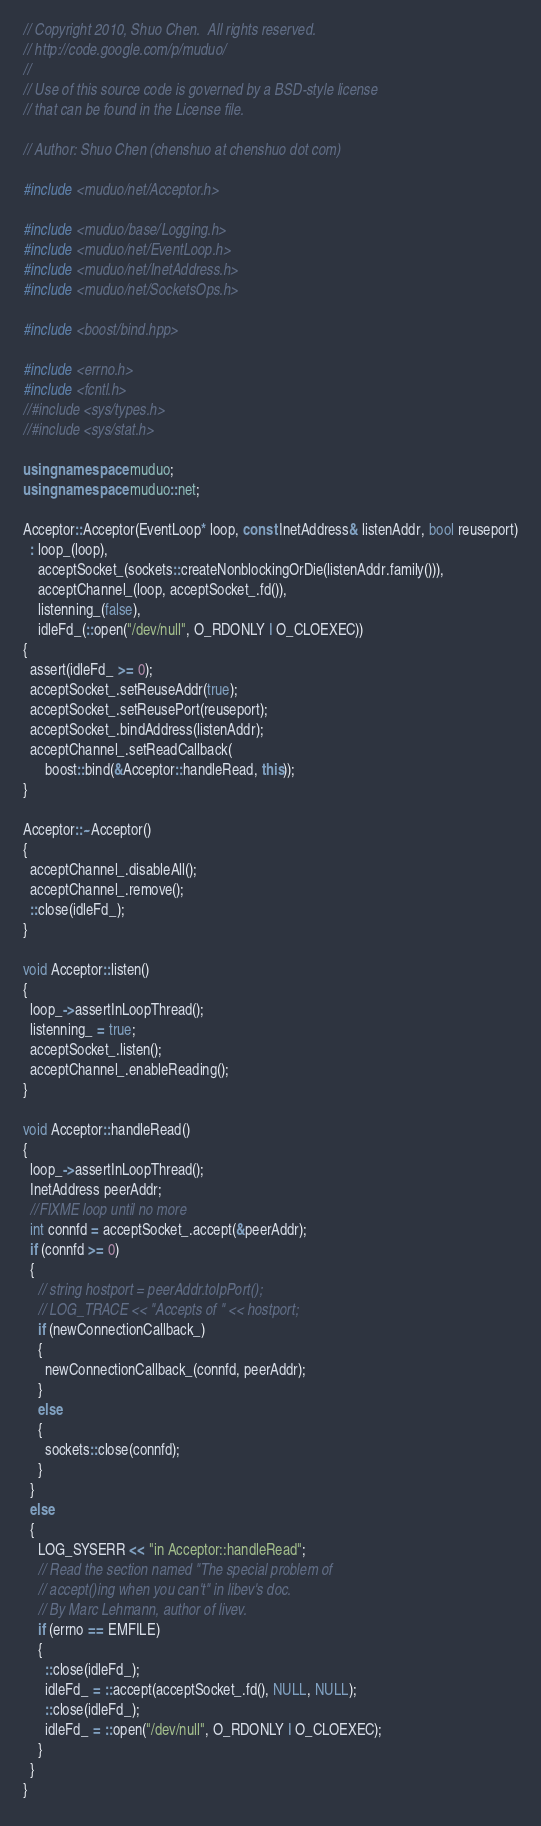<code> <loc_0><loc_0><loc_500><loc_500><_C++_>// Copyright 2010, Shuo Chen.  All rights reserved.
// http://code.google.com/p/muduo/
//
// Use of this source code is governed by a BSD-style license
// that can be found in the License file.

// Author: Shuo Chen (chenshuo at chenshuo dot com)

#include <muduo/net/Acceptor.h>

#include <muduo/base/Logging.h>
#include <muduo/net/EventLoop.h>
#include <muduo/net/InetAddress.h>
#include <muduo/net/SocketsOps.h>

#include <boost/bind.hpp>

#include <errno.h>
#include <fcntl.h>
//#include <sys/types.h>
//#include <sys/stat.h>

using namespace muduo;
using namespace muduo::net;

Acceptor::Acceptor(EventLoop* loop, const InetAddress& listenAddr, bool reuseport)
  : loop_(loop),
    acceptSocket_(sockets::createNonblockingOrDie(listenAddr.family())),
    acceptChannel_(loop, acceptSocket_.fd()),
    listenning_(false),
    idleFd_(::open("/dev/null", O_RDONLY | O_CLOEXEC))
{
  assert(idleFd_ >= 0);
  acceptSocket_.setReuseAddr(true);
  acceptSocket_.setReusePort(reuseport);
  acceptSocket_.bindAddress(listenAddr);
  acceptChannel_.setReadCallback(
      boost::bind(&Acceptor::handleRead, this));
}

Acceptor::~Acceptor()
{
  acceptChannel_.disableAll();
  acceptChannel_.remove();
  ::close(idleFd_);
}

void Acceptor::listen()
{
  loop_->assertInLoopThread();
  listenning_ = true;
  acceptSocket_.listen();
  acceptChannel_.enableReading();
}

void Acceptor::handleRead()
{
  loop_->assertInLoopThread();
  InetAddress peerAddr;
  //FIXME loop until no more
  int connfd = acceptSocket_.accept(&peerAddr);
  if (connfd >= 0)
  {
    // string hostport = peerAddr.toIpPort();
    // LOG_TRACE << "Accepts of " << hostport;
    if (newConnectionCallback_)
    {
      newConnectionCallback_(connfd, peerAddr);
    }
    else
    {
      sockets::close(connfd);
    }
  }
  else
  {
    LOG_SYSERR << "in Acceptor::handleRead";
    // Read the section named "The special problem of
    // accept()ing when you can't" in libev's doc.
    // By Marc Lehmann, author of livev.
    if (errno == EMFILE)
    {
      ::close(idleFd_);
      idleFd_ = ::accept(acceptSocket_.fd(), NULL, NULL);
      ::close(idleFd_);
      idleFd_ = ::open("/dev/null", O_RDONLY | O_CLOEXEC);
    }
  }
}

</code> 